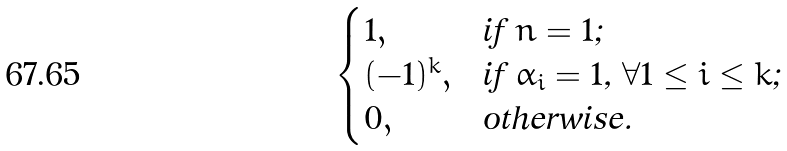<formula> <loc_0><loc_0><loc_500><loc_500>\begin{cases} 1 , & \text {if $n = 1$; } \\ ( - 1 ) ^ { k } , & \text {if $\alpha_{i} = 1$, $\forall 1 \leq i \leq k$; } \\ 0 , & \text {otherwise.} \end{cases}</formula> 